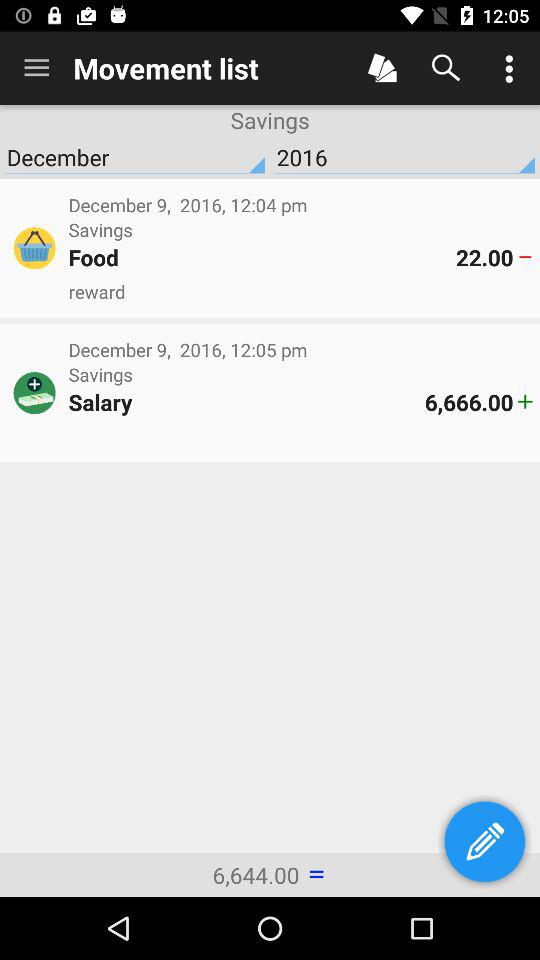What is the total salary in the savings account? The total salary is 6,666. 